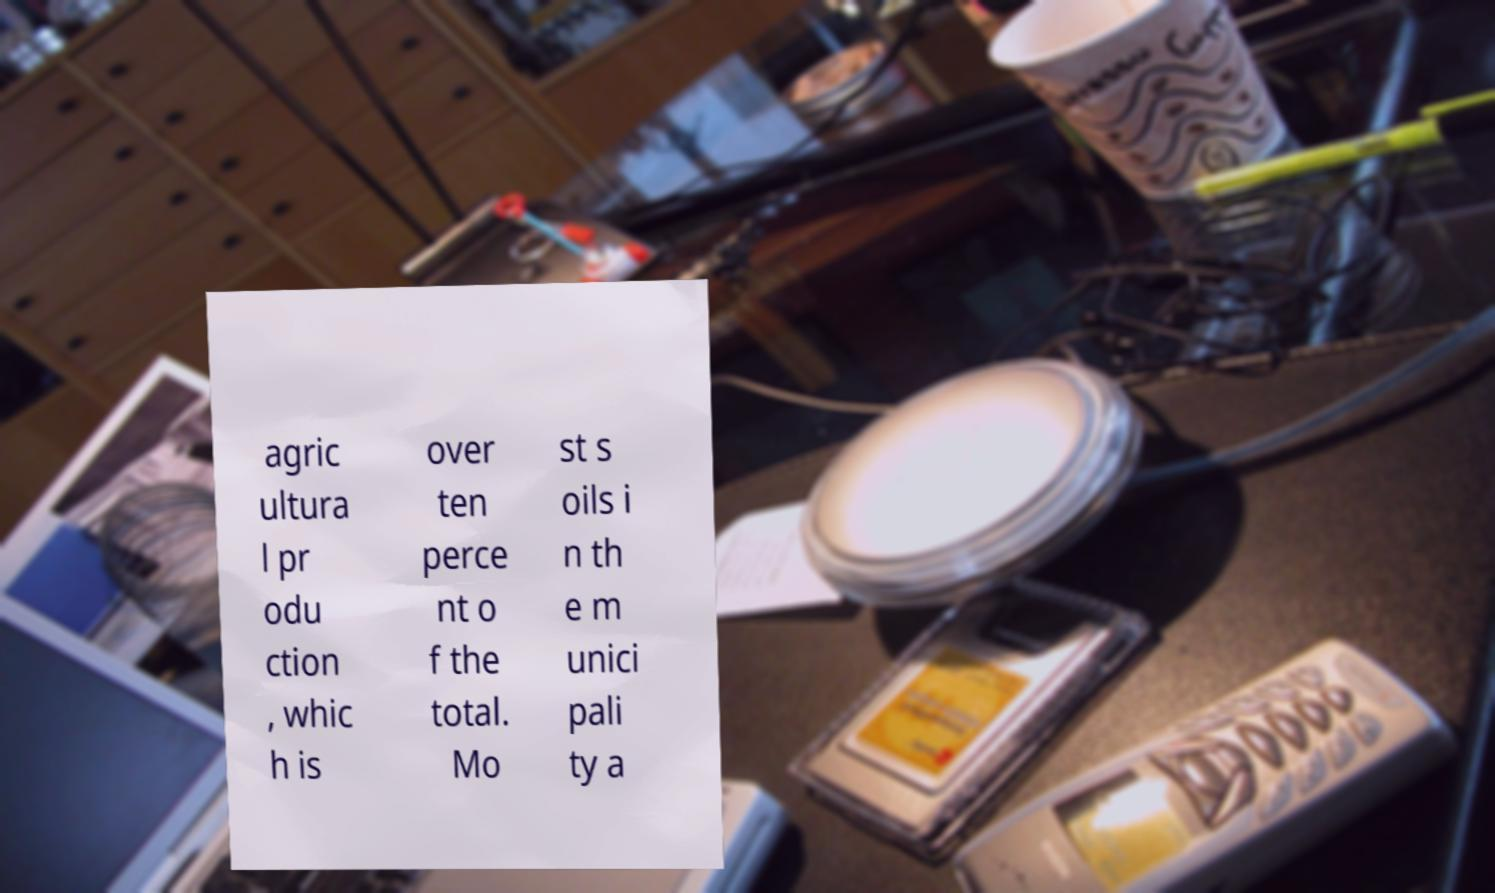Can you accurately transcribe the text from the provided image for me? agric ultura l pr odu ction , whic h is over ten perce nt o f the total. Mo st s oils i n th e m unici pali ty a 